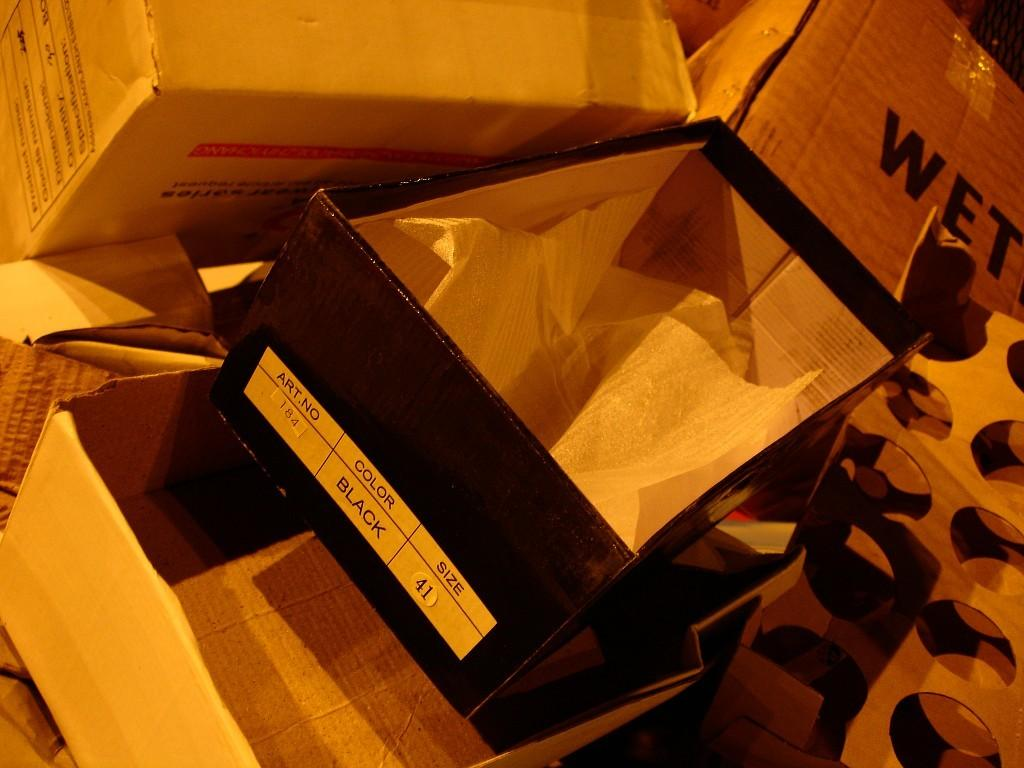<image>
Summarize the visual content of the image. An empty box once held a pair of black shoes in a size 41. 